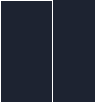Convert code to text. <code><loc_0><loc_0><loc_500><loc_500><_YAML_>
</code> 